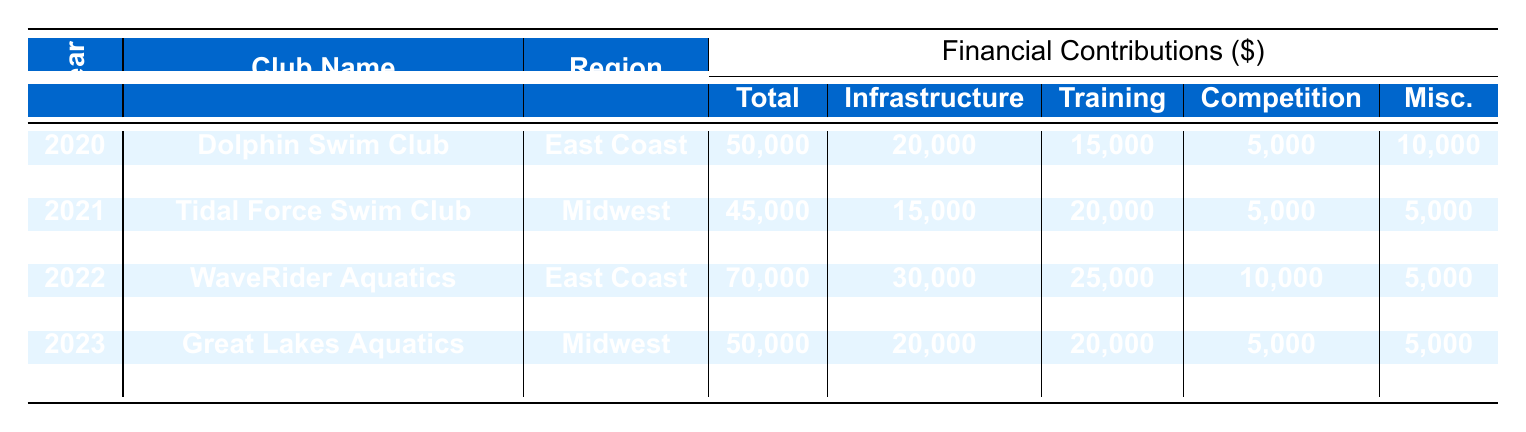What is the total contribution amount for the Dolphin Swim Club in 2020? The table indicates that the total contribution amount for Dolphin Swim Club is listed directly under the Total Contribution column for the year 2020, which shows 50,000.
Answer: 50,000 Which club received the highest total contribution in 2022? By comparing the Total Contribution amounts for both clubs in 2022, WaveRider Aquatics received 70,000 while Pacific Tsunami Swim Team received 80,000. Since 80,000 is higher, it is the highest contribution in that year.
Answer: Pacific Tsunami Swim Team What is the total infrastructure funding allocated to clubs in 2021? To find the total infrastructure funding for 2021, we add the Infrastructure Funding column for both clubs. Tidal Force Swim Club has 15,000 and Streamline Swimming Club has 20,000. Adding these gives 15,000 + 20,000 = 35,000.
Answer: 35,000 Did the Great Lakes Aquatics club receive more funding in 2023 than in 2021? Comparing the Total Contributions, Great Lakes Aquatics received 50,000 in 2023 and 45,000 in 2021. Since 50,000 is greater than 45,000, the answer is yes.
Answer: Yes What was the average total contribution across all clubs in 2020? To find the average total contribution in 2020, first, we sum the Total Contributions for that year: 50,000 (Dolphin Swim Club) + 60,000 (Blue Wave Aquatics) = 110,000. Since there are two clubs, we divide by 2, giving 110,000 / 2 = 55,000.
Answer: 55,000 Which region received the least contribution in 2021? By examining the Total Contributions for clubs in 2021, Tidal Force Swim Club (Midwest) received 45,000 and Streamline Swimming Club (Southwest) received 55,000. Since 45,000 is lower, the Midwest region received the least.
Answer: Midwest Is the competition fees amount for Desert Splash Swim Club in 2023 higher than the training programs funding for Tidal Force Swim Club in 2021? The competition fees for Desert Splash Swim Club in 2023 are 5,000, while the training programs funding for Tidal Force Swim Club in 2021 is 20,000. Since 5,000 is less than 20,000, the answer is no.
Answer: No What is the difference in total contributions between the Pacific Tsunami Swim Team in 2022 and the Blue Wave Aquatics in 2020? The total contributions are 80,000 for Pacific Tsunami Swim Team in 2022 and 60,000 for Blue Wave Aquatics in 2020. The difference is 80,000 - 60,000 = 20,000.
Answer: 20,000 What percentage of the total contribution for the Dolphin Swim Club in 2020 was allocated to training programs? The training programs funding for Dolphin Swim Club in 2020 was 15,000 out of a total contribution of 50,000. To find the percentage, we calculate (15,000 / 50,000) * 100 = 30%.
Answer: 30% 